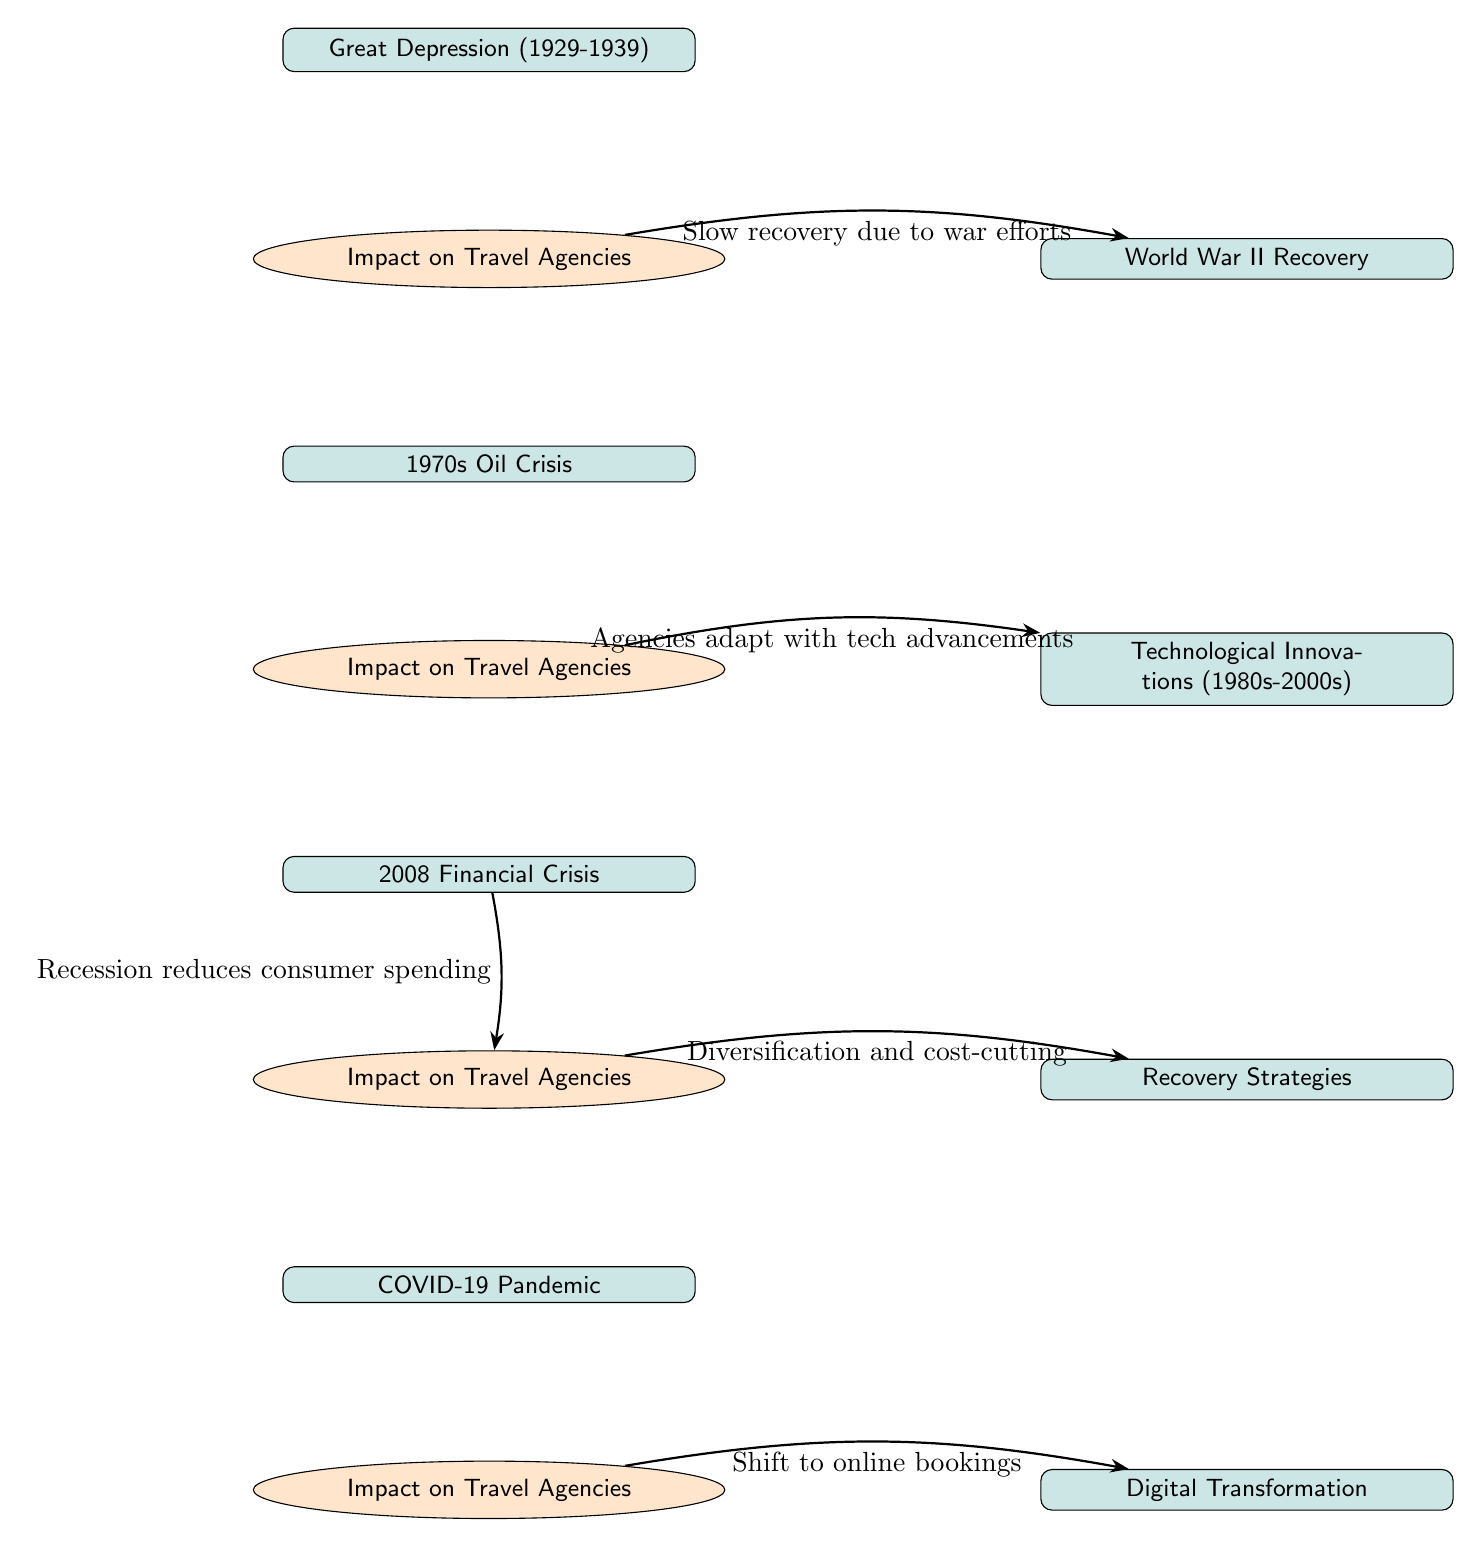What event occurred from 1929 to 1939? The event that took place during this period is the Great Depression. This information is clearly labeled in the diagram, showing the time frame associated with the economic downturn.
Answer: Great Depression (1929-1939) What is the impact of the Great Depression on travel agencies? The impact of the Great Depression on travel agencies is described as "High unemployment rates, reduced travel". This is a direct connection indicated in the diagram from the Great Depression event node to the respective impact node.
Answer: High unemployment rates, reduced travel What strategy was associated with the 2008 Financial Crisis impact? The diagram indicates that the 2008 Financial Crisis led to "Diversification and cost-cutting" as a recovery strategy. This is noted directly under the impact node connected to the financial crisis node.
Answer: Diversification and cost-cutting Which major conflict is identified in the recovery phase after the Great Depression? Following the Great Depression, the diagram indicates "World War II Recovery" as the major conflict leading to recovery strategies. This relationship flows directly from the Great Depression impact node to the WWII recovery node.
Answer: World War II Recovery How many economic downturn events are included in the diagram? The diagram lists four key economic downturn events: Great Depression, 1970s Oil Crisis, 2008 Financial Crisis, and COVID-19 Pandemic. Counting each of these event nodes gives a total of four.
Answer: 4 What was the main impact of COVID-19 on travel agencies? The impact of COVID-19 as depicted in the diagram is labeled "Global lockdowns, revenue losses". This detail is specified directly under the COVID-19 event node leading to the associated impact.
Answer: Global lockdowns, revenue losses What transformation is connected to the impact of the COVID-19 pandemic on travel agencies? The impact leads to a transformation described as "Shift to online bookings," which is an adaptation travel agencies undertook in response to the pandemic’s impact. The link from the impact node to the digital transformation node represents this connection.
Answer: Shift to online bookings What trend does the 1970s Oil Crisis impact lead to in travel agencies? The impact of the 1970s Oil Crisis led to travel agencies adapting with "tech advancements." This is illustrated in the diagram showing a flow from the oil crisis impact to the technological innovations event node.
Answer: Agencies adapt with tech advancements What relationship exists between the 2008 Financial Crisis and the recovery strategies? The diagram shows a direct relationship where the impact of the 2008 Financial Crisis resulted in "Diversification and cost-cutting" leading to recovery strategies, effectively connecting the two nodes.
Answer: Diversification and cost-cutting 